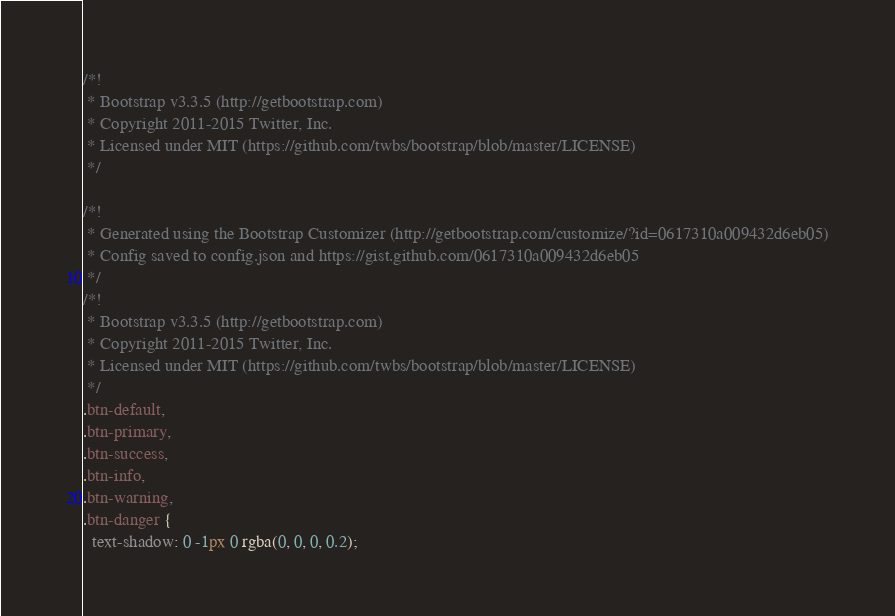<code> <loc_0><loc_0><loc_500><loc_500><_CSS_>/*!
 * Bootstrap v3.3.5 (http://getbootstrap.com)
 * Copyright 2011-2015 Twitter, Inc.
 * Licensed under MIT (https://github.com/twbs/bootstrap/blob/master/LICENSE)
 */

/*!
 * Generated using the Bootstrap Customizer (http://getbootstrap.com/customize/?id=0617310a009432d6eb05)
 * Config saved to config.json and https://gist.github.com/0617310a009432d6eb05
 */
/*!
 * Bootstrap v3.3.5 (http://getbootstrap.com)
 * Copyright 2011-2015 Twitter, Inc.
 * Licensed under MIT (https://github.com/twbs/bootstrap/blob/master/LICENSE)
 */
.btn-default,
.btn-primary,
.btn-success,
.btn-info,
.btn-warning,
.btn-danger {
  text-shadow: 0 -1px 0 rgba(0, 0, 0, 0.2);</code> 